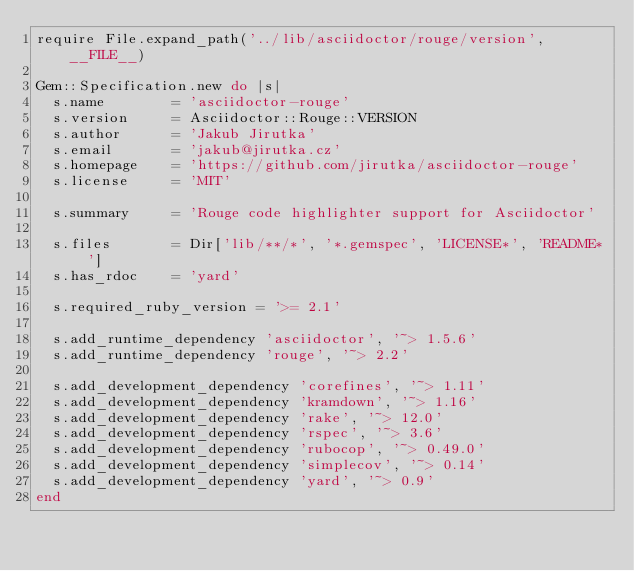<code> <loc_0><loc_0><loc_500><loc_500><_Ruby_>require File.expand_path('../lib/asciidoctor/rouge/version', __FILE__)

Gem::Specification.new do |s|
  s.name        = 'asciidoctor-rouge'
  s.version     = Asciidoctor::Rouge::VERSION
  s.author      = 'Jakub Jirutka'
  s.email       = 'jakub@jirutka.cz'
  s.homepage    = 'https://github.com/jirutka/asciidoctor-rouge'
  s.license     = 'MIT'

  s.summary     = 'Rouge code highlighter support for Asciidoctor'

  s.files       = Dir['lib/**/*', '*.gemspec', 'LICENSE*', 'README*']
  s.has_rdoc    = 'yard'

  s.required_ruby_version = '>= 2.1'

  s.add_runtime_dependency 'asciidoctor', '~> 1.5.6'
  s.add_runtime_dependency 'rouge', '~> 2.2'

  s.add_development_dependency 'corefines', '~> 1.11'
  s.add_development_dependency 'kramdown', '~> 1.16'
  s.add_development_dependency 'rake', '~> 12.0'
  s.add_development_dependency 'rspec', '~> 3.6'
  s.add_development_dependency 'rubocop', '~> 0.49.0'
  s.add_development_dependency 'simplecov', '~> 0.14'
  s.add_development_dependency 'yard', '~> 0.9'
end
</code> 